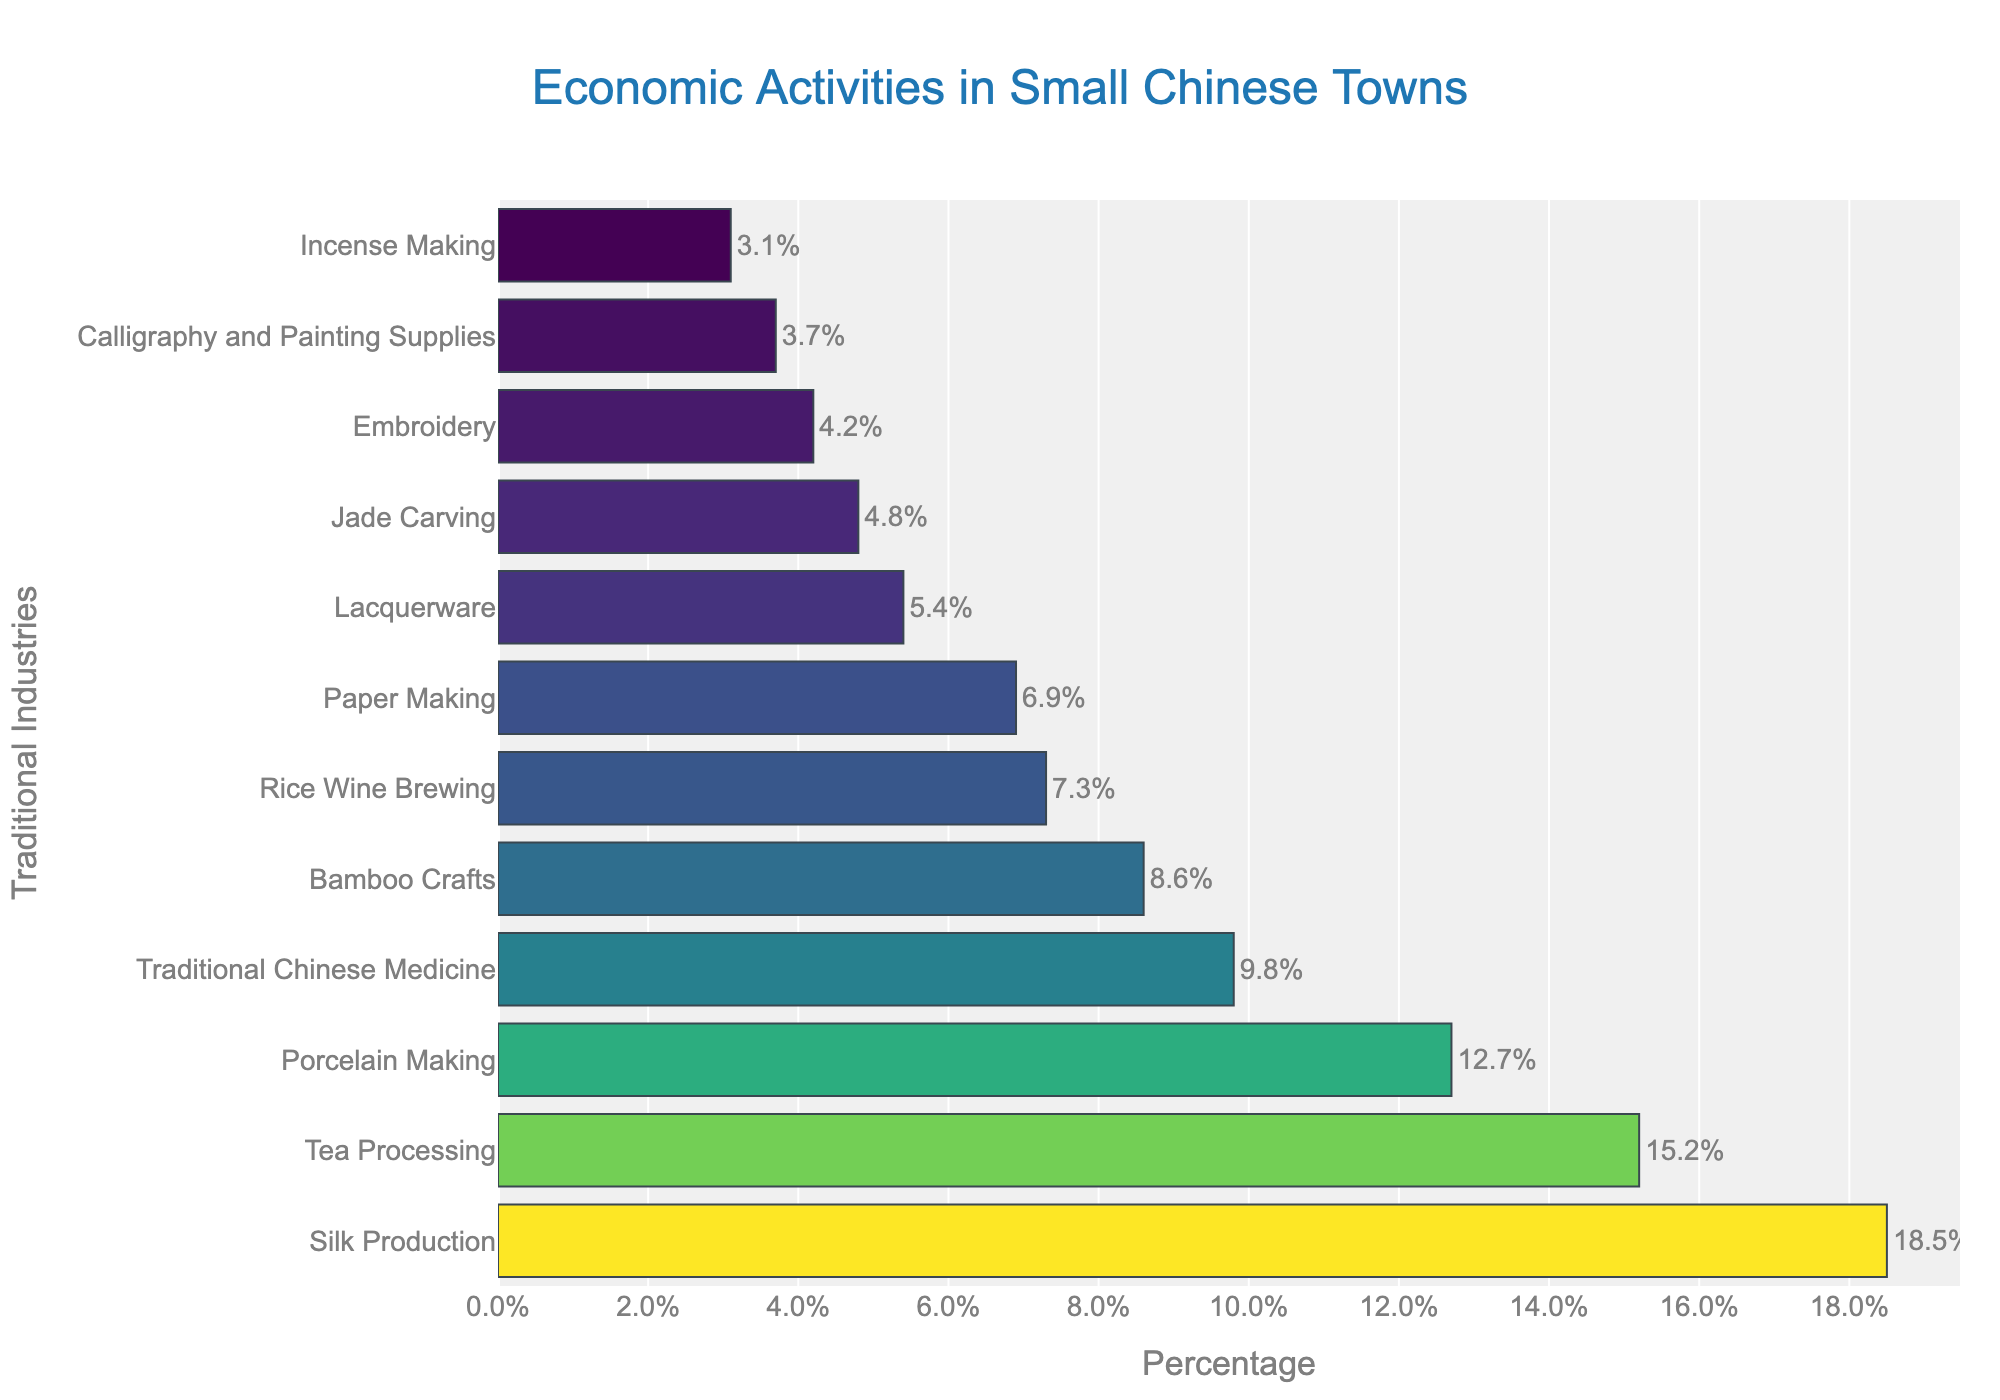Which traditional industry has the highest economic activity percentage? Silk Production is at the top of the bar chart with the highest percentage at 18.5%.
Answer: Silk Production Which two industries combined make up approximately 28% of the economic activity? Silk Production (18.5%) and Rice Wine Brewing (7.3%) together make up 25.8%, while Silk Production (18.5%) and Bamboo Crafts (8.6%) together make up 27.1%, but none make exactly 28%. Since the Silk Production and Bamboo Crafts combined percentage is closest to 28%, they would be the correct pair
Answer: Silk Production and Bamboo Crafts What is the difference in economic activity percentage between Calligraphy and Painting Supplies and Embroidery? Calligraphy and Painting Supplies have 3.7% and Embroidery has 4.2%, a difference of 4.2% - 3.7% = 0.5%.
Answer: 0.5% How many industries have economic activity percentages greater than 10%? There are three bars representing industries with percentages greater than 10%: Silk Production (18.5%), Tea Processing (15.2%), and Porcelain Making (12.7%).
Answer: 3 Among Ink and Lacquerware, which has a smaller economic activity percentage? Lacquerware has a percentage of 5.4%, and since Ink is not in the list, Lacquerware by default has the smaller percentage.
Answer: Lacquerware What is the combined economic activity percentage of the three least prevalent industries? The three least prevalent industries are Incense Making (3.1%), Calligraphy and Painting Supplies (3.7%), and Embroidery (4.2%). Their combined percentage is 3.1% + 3.7% + 4.2% = 11.0%.
Answer: 11.0% Is Tea Processing more predominant than Rice Wine Brewing? Yes, Tea Processing has a percentage of 15.2%, while Rice Wine Brewing has 7.3%. 15.2% is greater than 7.3%.
Answer: Yes Which industry visually has the longest bar in the chart? The Silk Production bar is visibly the longest, indicating it has the highest economic activity percentage.
Answer: Silk Production What is the approximate percentage difference between the highest and lowest economic activity industries? The highest is Silk Production at 18.5%, and the lowest is Incense Making at 3.1%. The percentage difference is 18.5% - 3.1% = 15.4%.
Answer: 15.4% How does Bamboo Crafts rank in terms of economic activity percentage among the listed industries? Bamboo Crafts are shown as the fifth bar from the top with a percentage of 8.6%, ranking it fifth highest in terms of economic activity.
Answer: Fifth 